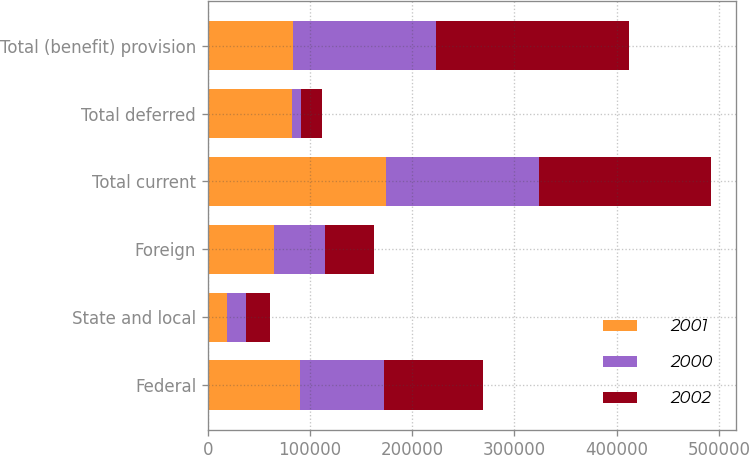Convert chart to OTSL. <chart><loc_0><loc_0><loc_500><loc_500><stacked_bar_chart><ecel><fcel>Federal<fcel>State and local<fcel>Foreign<fcel>Total current<fcel>Total deferred<fcel>Total (benefit) provision<nl><fcel>2001<fcel>90312<fcel>19110<fcel>64922<fcel>174344<fcel>82124<fcel>82864<nl><fcel>2000<fcel>82124<fcel>17828<fcel>49886<fcel>149838<fcel>9083<fcel>140755<nl><fcel>2002<fcel>96864<fcel>23498<fcel>47387<fcel>167749<fcel>20361<fcel>188110<nl></chart> 